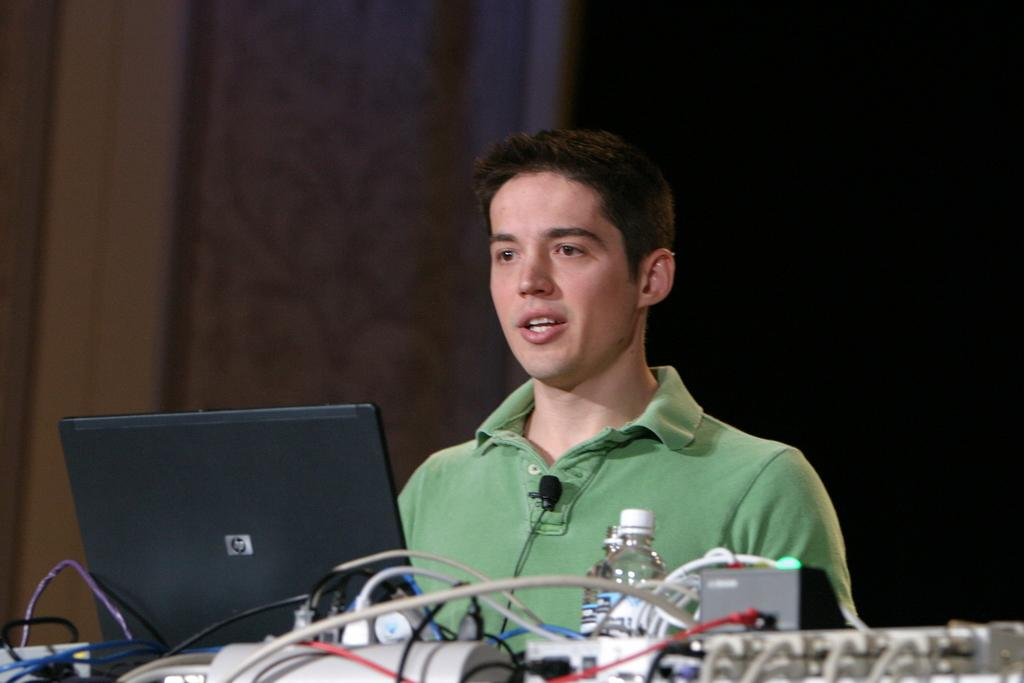Who or what is the main subject in the image? There is a person in the image. What is the person interacting with in the image? There is a laptop in front of the person. What other object can be seen in the image? There is a bottle in the image. Are there any objects with cables visible in the image? Yes, there are other objects with cables in the image. How would you describe the background of the image? The background of the image is dark. How many impulses can be seen in the image? There are no impulses visible in the image. Is there a cobweb in the image? There is no cobweb present in the image. 